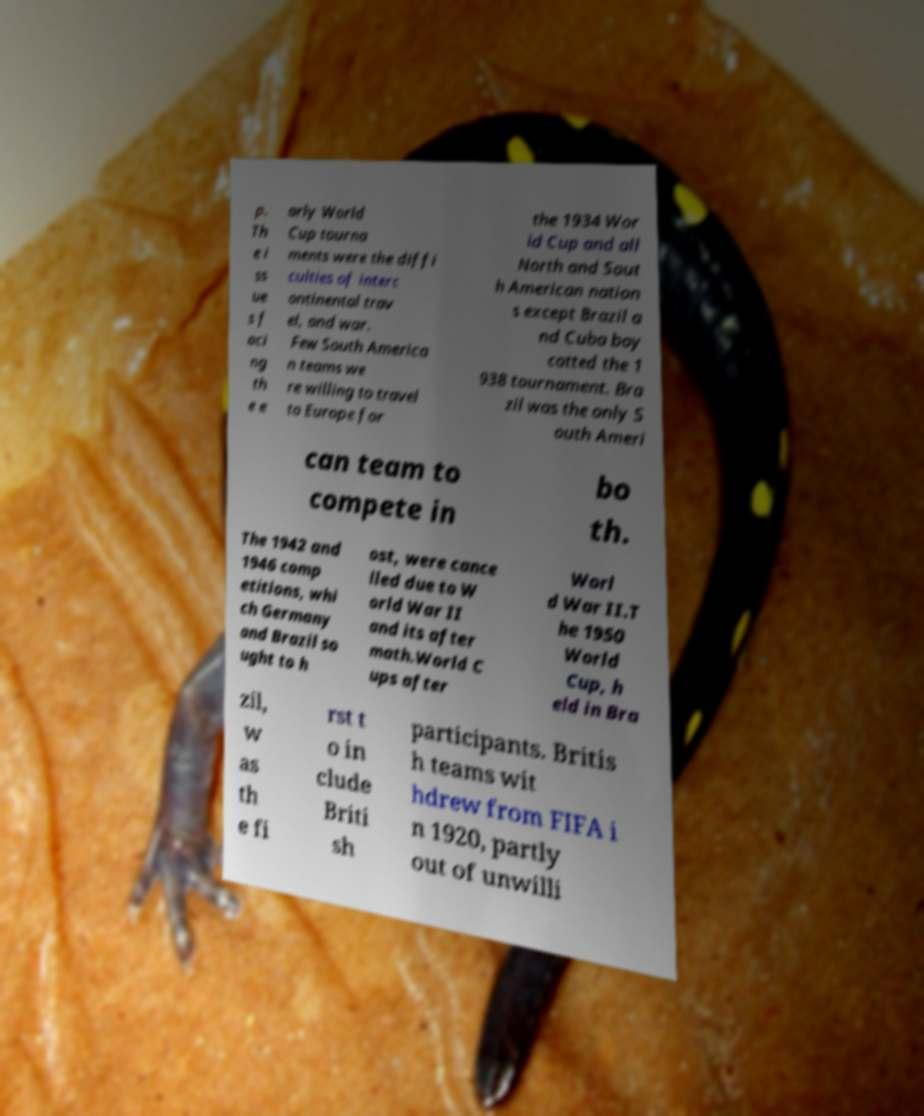Could you assist in decoding the text presented in this image and type it out clearly? p. Th e i ss ue s f aci ng th e e arly World Cup tourna ments were the diffi culties of interc ontinental trav el, and war. Few South America n teams we re willing to travel to Europe for the 1934 Wor ld Cup and all North and Sout h American nation s except Brazil a nd Cuba boy cotted the 1 938 tournament. Bra zil was the only S outh Ameri can team to compete in bo th. The 1942 and 1946 comp etitions, whi ch Germany and Brazil so ught to h ost, were cance lled due to W orld War II and its after math.World C ups after Worl d War II.T he 1950 World Cup, h eld in Bra zil, w as th e fi rst t o in clude Briti sh participants. Britis h teams wit hdrew from FIFA i n 1920, partly out of unwilli 